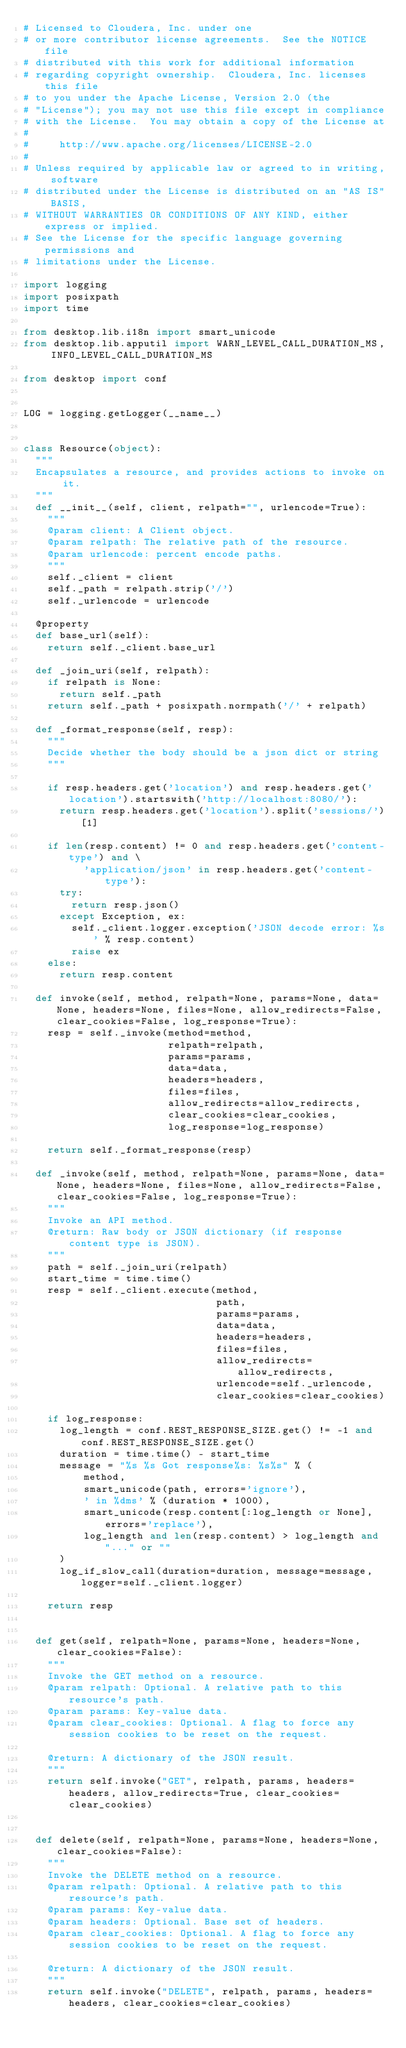<code> <loc_0><loc_0><loc_500><loc_500><_Python_># Licensed to Cloudera, Inc. under one
# or more contributor license agreements.  See the NOTICE file
# distributed with this work for additional information
# regarding copyright ownership.  Cloudera, Inc. licenses this file
# to you under the Apache License, Version 2.0 (the
# "License"); you may not use this file except in compliance
# with the License.  You may obtain a copy of the License at
#
#     http://www.apache.org/licenses/LICENSE-2.0
#
# Unless required by applicable law or agreed to in writing, software
# distributed under the License is distributed on an "AS IS" BASIS,
# WITHOUT WARRANTIES OR CONDITIONS OF ANY KIND, either express or implied.
# See the License for the specific language governing permissions and
# limitations under the License.

import logging
import posixpath
import time

from desktop.lib.i18n import smart_unicode
from desktop.lib.apputil import WARN_LEVEL_CALL_DURATION_MS, INFO_LEVEL_CALL_DURATION_MS

from desktop import conf


LOG = logging.getLogger(__name__)


class Resource(object):
  """
  Encapsulates a resource, and provides actions to invoke on it.
  """
  def __init__(self, client, relpath="", urlencode=True):
    """
    @param client: A Client object.
    @param relpath: The relative path of the resource.
    @param urlencode: percent encode paths.
    """
    self._client = client
    self._path = relpath.strip('/')
    self._urlencode = urlencode

  @property
  def base_url(self):
    return self._client.base_url

  def _join_uri(self, relpath):
    if relpath is None:
      return self._path
    return self._path + posixpath.normpath('/' + relpath)

  def _format_response(self, resp):
    """
    Decide whether the body should be a json dict or string
    """

    if resp.headers.get('location') and resp.headers.get('location').startswith('http://localhost:8080/'):
      return resp.headers.get('location').split('sessions/')[1]

    if len(resp.content) != 0 and resp.headers.get('content-type') and \
          'application/json' in resp.headers.get('content-type'):
      try:
        return resp.json()
      except Exception, ex:
        self._client.logger.exception('JSON decode error: %s' % resp.content)
        raise ex
    else:
      return resp.content

  def invoke(self, method, relpath=None, params=None, data=None, headers=None, files=None, allow_redirects=False, clear_cookies=False, log_response=True):
    resp = self._invoke(method=method,
                        relpath=relpath,
                        params=params,
                        data=data,
                        headers=headers,
                        files=files,
                        allow_redirects=allow_redirects,
                        clear_cookies=clear_cookies,
                        log_response=log_response)

    return self._format_response(resp)

  def _invoke(self, method, relpath=None, params=None, data=None, headers=None, files=None, allow_redirects=False, clear_cookies=False, log_response=True):
    """
    Invoke an API method.
    @return: Raw body or JSON dictionary (if response content type is JSON).
    """
    path = self._join_uri(relpath)
    start_time = time.time()
    resp = self._client.execute(method,
                                path,
                                params=params,
                                data=data,
                                headers=headers,
                                files=files,
                                allow_redirects=allow_redirects,
                                urlencode=self._urlencode,
                                clear_cookies=clear_cookies)

    if log_response:
      log_length = conf.REST_RESPONSE_SIZE.get() != -1 and conf.REST_RESPONSE_SIZE.get()
      duration = time.time() - start_time
      message = "%s %s Got response%s: %s%s" % (
          method,
          smart_unicode(path, errors='ignore'),
          ' in %dms' % (duration * 1000),
          smart_unicode(resp.content[:log_length or None], errors='replace'),
          log_length and len(resp.content) > log_length and "..." or ""
      )
      log_if_slow_call(duration=duration, message=message, logger=self._client.logger)

    return resp


  def get(self, relpath=None, params=None, headers=None, clear_cookies=False):
    """
    Invoke the GET method on a resource.
    @param relpath: Optional. A relative path to this resource's path.
    @param params: Key-value data.
    @param clear_cookies: Optional. A flag to force any session cookies to be reset on the request.

    @return: A dictionary of the JSON result.
    """
    return self.invoke("GET", relpath, params, headers=headers, allow_redirects=True, clear_cookies=clear_cookies)


  def delete(self, relpath=None, params=None, headers=None, clear_cookies=False):
    """
    Invoke the DELETE method on a resource.
    @param relpath: Optional. A relative path to this resource's path.
    @param params: Key-value data.
    @param headers: Optional. Base set of headers.
    @param clear_cookies: Optional. A flag to force any session cookies to be reset on the request.

    @return: A dictionary of the JSON result.
    """
    return self.invoke("DELETE", relpath, params, headers=headers, clear_cookies=clear_cookies)

</code> 